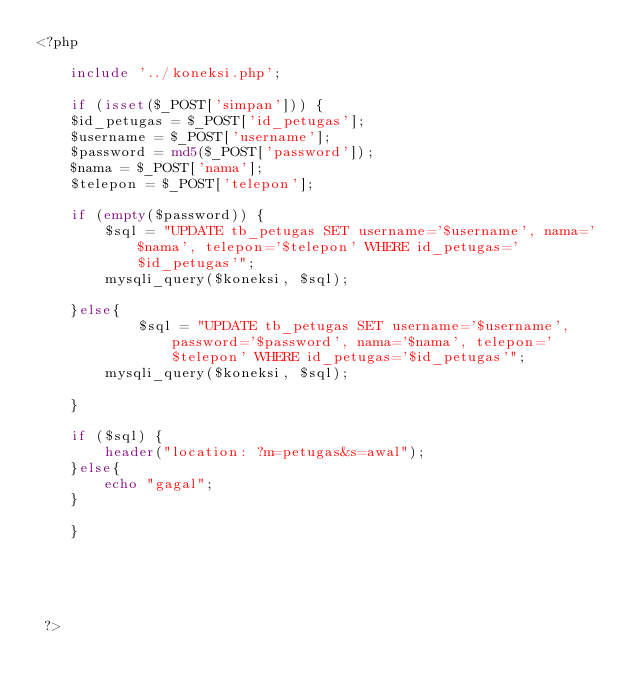Convert code to text. <code><loc_0><loc_0><loc_500><loc_500><_PHP_><?php 
	
	include '../koneksi.php';

	if (isset($_POST['simpan'])) {
	$id_petugas = $_POST['id_petugas'];
	$username = $_POST['username'];
	$password = md5($_POST['password']);
	$nama = $_POST['nama'];
	$telepon = $_POST['telepon'];

	if (empty($password)) {
		$sql = "UPDATE tb_petugas SET username='$username', nama='$nama', telepon='$telepon' WHERE id_petugas='$id_petugas'";
		mysqli_query($koneksi, $sql);

	}else{
			$sql = "UPDATE tb_petugas SET username='$username', password='$password', nama='$nama', telepon='$telepon' WHERE id_petugas='$id_petugas'";
		mysqli_query($koneksi, $sql);

	}

	if ($sql) {
		header("location: ?m=petugas&s=awal");
	}else{
		echo "gagal";
	}

	}





 ?></code> 